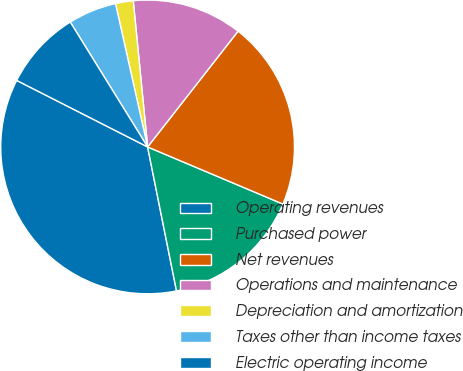Convert chart. <chart><loc_0><loc_0><loc_500><loc_500><pie_chart><fcel>Operating revenues<fcel>Purchased power<fcel>Net revenues<fcel>Operations and maintenance<fcel>Depreciation and amortization<fcel>Taxes other than income taxes<fcel>Electric operating income<nl><fcel>35.64%<fcel>15.49%<fcel>20.8%<fcel>12.12%<fcel>1.95%<fcel>5.32%<fcel>8.69%<nl></chart> 